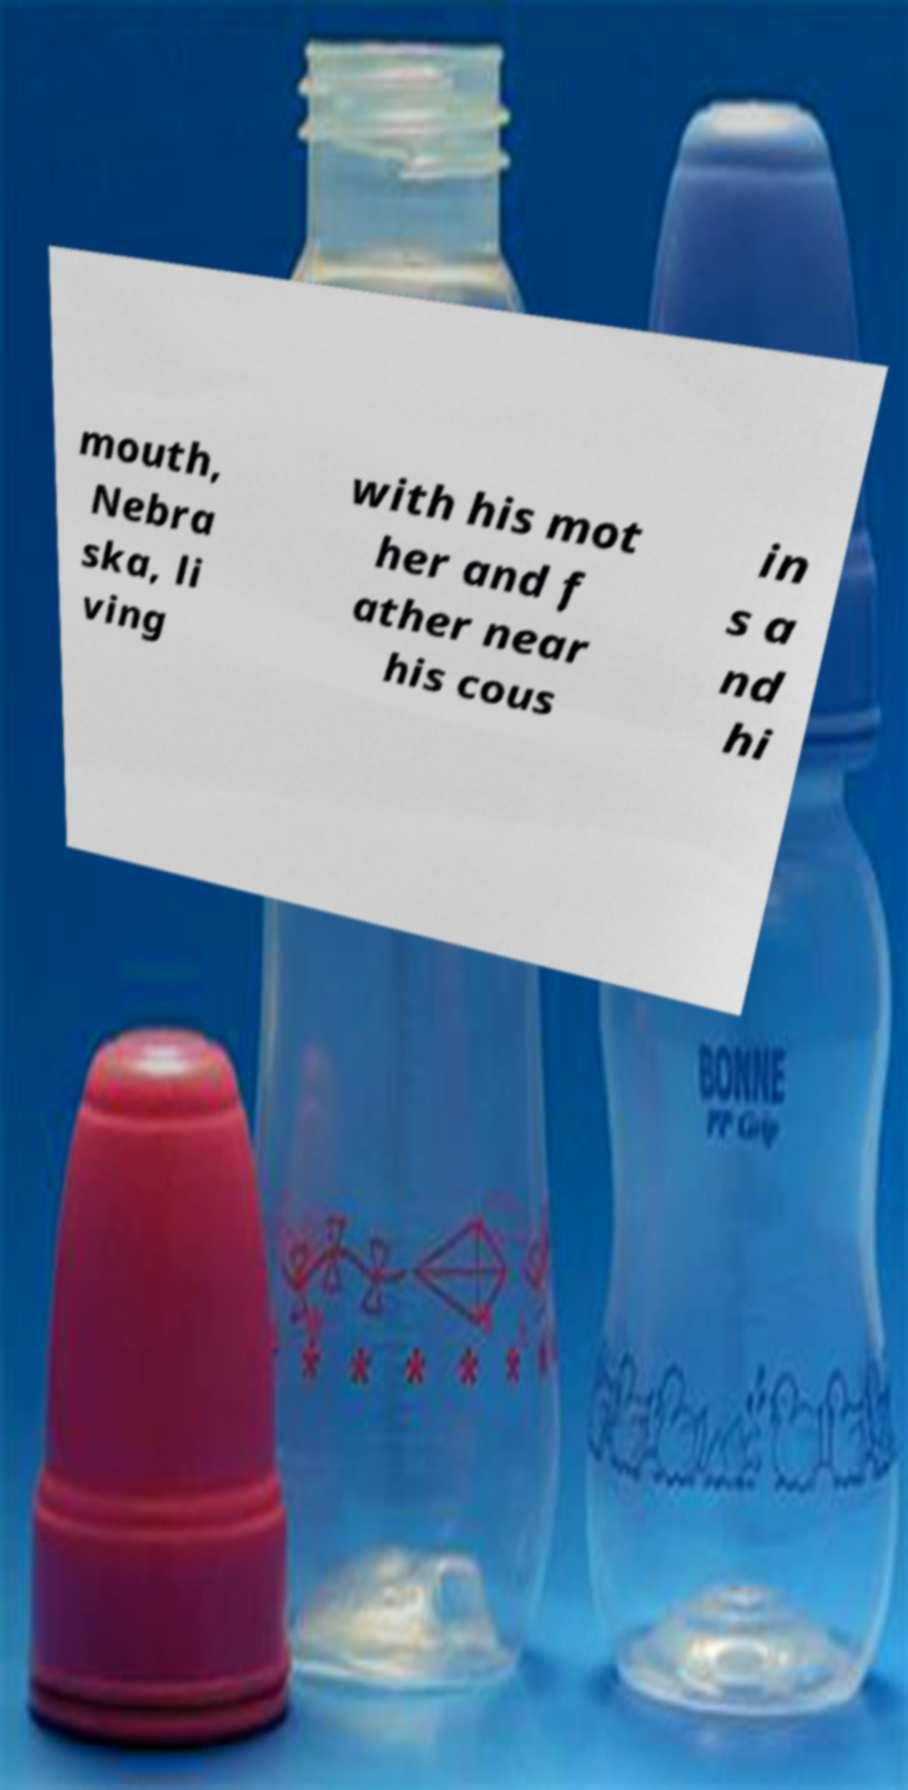Please read and relay the text visible in this image. What does it say? mouth, Nebra ska, li ving with his mot her and f ather near his cous in s a nd hi 